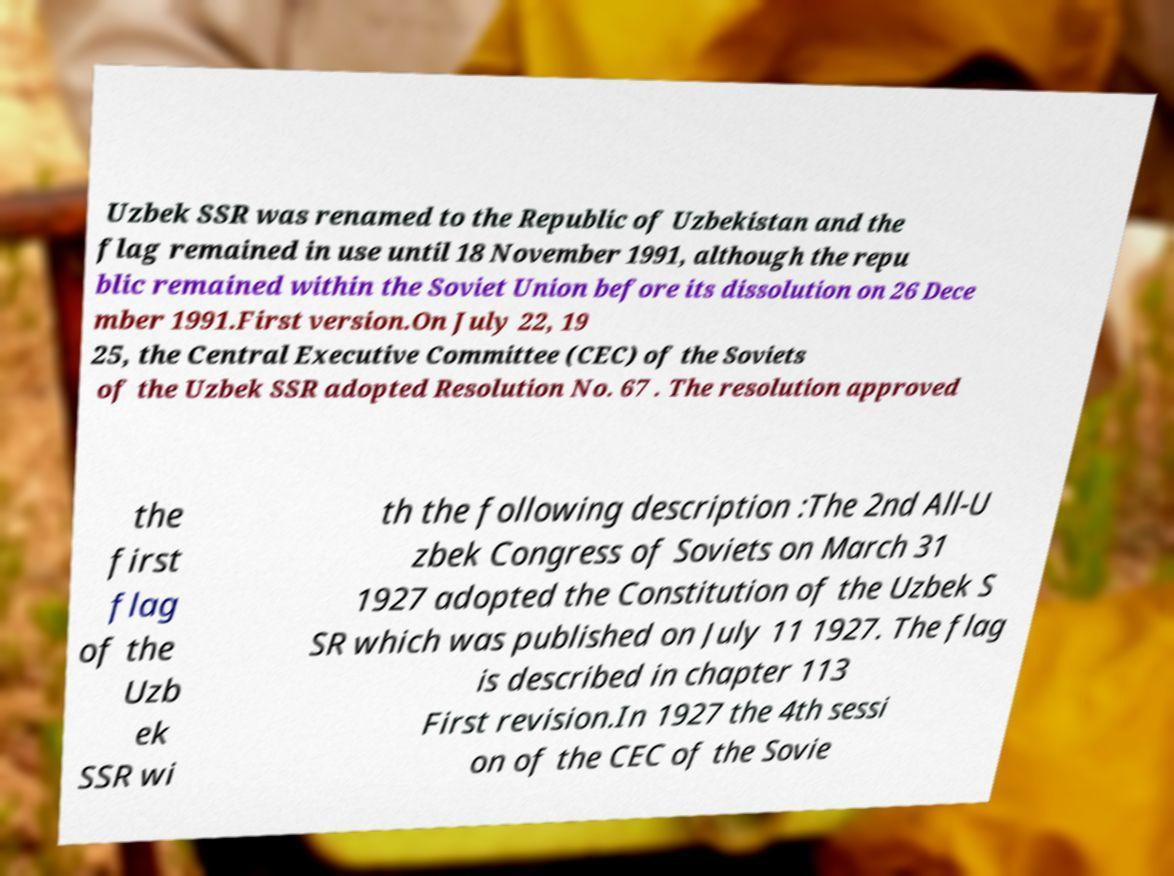Please read and relay the text visible in this image. What does it say? Uzbek SSR was renamed to the Republic of Uzbekistan and the flag remained in use until 18 November 1991, although the repu blic remained within the Soviet Union before its dissolution on 26 Dece mber 1991.First version.On July 22, 19 25, the Central Executive Committee (CEC) of the Soviets of the Uzbek SSR adopted Resolution No. 67 . The resolution approved the first flag of the Uzb ek SSR wi th the following description :The 2nd All-U zbek Congress of Soviets on March 31 1927 adopted the Constitution of the Uzbek S SR which was published on July 11 1927. The flag is described in chapter 113 First revision.In 1927 the 4th sessi on of the CEC of the Sovie 